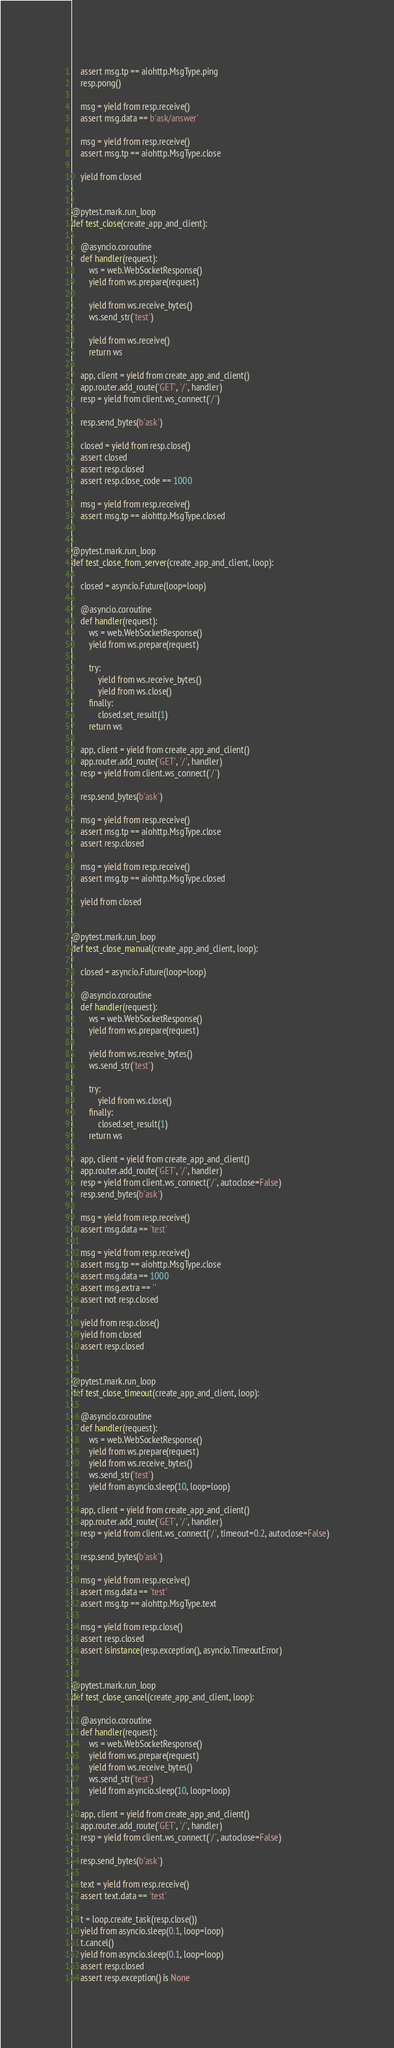Convert code to text. <code><loc_0><loc_0><loc_500><loc_500><_Python_>    assert msg.tp == aiohttp.MsgType.ping
    resp.pong()

    msg = yield from resp.receive()
    assert msg.data == b'ask/answer'

    msg = yield from resp.receive()
    assert msg.tp == aiohttp.MsgType.close

    yield from closed


@pytest.mark.run_loop
def test_close(create_app_and_client):

    @asyncio.coroutine
    def handler(request):
        ws = web.WebSocketResponse()
        yield from ws.prepare(request)

        yield from ws.receive_bytes()
        ws.send_str('test')

        yield from ws.receive()
        return ws

    app, client = yield from create_app_and_client()
    app.router.add_route('GET', '/', handler)
    resp = yield from client.ws_connect('/')

    resp.send_bytes(b'ask')

    closed = yield from resp.close()
    assert closed
    assert resp.closed
    assert resp.close_code == 1000

    msg = yield from resp.receive()
    assert msg.tp == aiohttp.MsgType.closed


@pytest.mark.run_loop
def test_close_from_server(create_app_and_client, loop):

    closed = asyncio.Future(loop=loop)

    @asyncio.coroutine
    def handler(request):
        ws = web.WebSocketResponse()
        yield from ws.prepare(request)

        try:
            yield from ws.receive_bytes()
            yield from ws.close()
        finally:
            closed.set_result(1)
        return ws

    app, client = yield from create_app_and_client()
    app.router.add_route('GET', '/', handler)
    resp = yield from client.ws_connect('/')

    resp.send_bytes(b'ask')

    msg = yield from resp.receive()
    assert msg.tp == aiohttp.MsgType.close
    assert resp.closed

    msg = yield from resp.receive()
    assert msg.tp == aiohttp.MsgType.closed

    yield from closed


@pytest.mark.run_loop
def test_close_manual(create_app_and_client, loop):

    closed = asyncio.Future(loop=loop)

    @asyncio.coroutine
    def handler(request):
        ws = web.WebSocketResponse()
        yield from ws.prepare(request)

        yield from ws.receive_bytes()
        ws.send_str('test')

        try:
            yield from ws.close()
        finally:
            closed.set_result(1)
        return ws

    app, client = yield from create_app_and_client()
    app.router.add_route('GET', '/', handler)
    resp = yield from client.ws_connect('/', autoclose=False)
    resp.send_bytes(b'ask')

    msg = yield from resp.receive()
    assert msg.data == 'test'

    msg = yield from resp.receive()
    assert msg.tp == aiohttp.MsgType.close
    assert msg.data == 1000
    assert msg.extra == ''
    assert not resp.closed

    yield from resp.close()
    yield from closed
    assert resp.closed


@pytest.mark.run_loop
def test_close_timeout(create_app_and_client, loop):

    @asyncio.coroutine
    def handler(request):
        ws = web.WebSocketResponse()
        yield from ws.prepare(request)
        yield from ws.receive_bytes()
        ws.send_str('test')
        yield from asyncio.sleep(10, loop=loop)

    app, client = yield from create_app_and_client()
    app.router.add_route('GET', '/', handler)
    resp = yield from client.ws_connect('/', timeout=0.2, autoclose=False)

    resp.send_bytes(b'ask')

    msg = yield from resp.receive()
    assert msg.data == 'test'
    assert msg.tp == aiohttp.MsgType.text

    msg = yield from resp.close()
    assert resp.closed
    assert isinstance(resp.exception(), asyncio.TimeoutError)


@pytest.mark.run_loop
def test_close_cancel(create_app_and_client, loop):

    @asyncio.coroutine
    def handler(request):
        ws = web.WebSocketResponse()
        yield from ws.prepare(request)
        yield from ws.receive_bytes()
        ws.send_str('test')
        yield from asyncio.sleep(10, loop=loop)

    app, client = yield from create_app_and_client()
    app.router.add_route('GET', '/', handler)
    resp = yield from client.ws_connect('/', autoclose=False)

    resp.send_bytes(b'ask')

    text = yield from resp.receive()
    assert text.data == 'test'

    t = loop.create_task(resp.close())
    yield from asyncio.sleep(0.1, loop=loop)
    t.cancel()
    yield from asyncio.sleep(0.1, loop=loop)
    assert resp.closed
    assert resp.exception() is None
</code> 